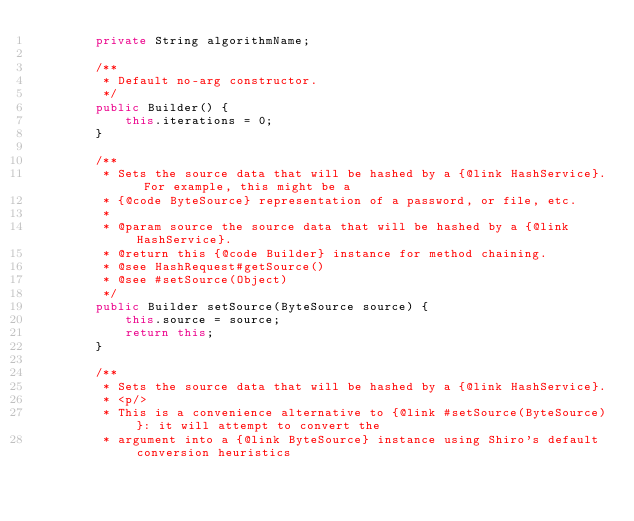Convert code to text. <code><loc_0><loc_0><loc_500><loc_500><_Java_>        private String algorithmName;

        /**
         * Default no-arg constructor.
         */
        public Builder() {
            this.iterations = 0;
        }

        /**
         * Sets the source data that will be hashed by a {@link HashService}. For example, this might be a
         * {@code ByteSource} representation of a password, or file, etc.
         *
         * @param source the source data that will be hashed by a {@link HashService}.
         * @return this {@code Builder} instance for method chaining.
         * @see HashRequest#getSource()
         * @see #setSource(Object)
         */
        public Builder setSource(ByteSource source) {
            this.source = source;
            return this;
        }

        /**
         * Sets the source data that will be hashed by a {@link HashService}.
         * <p/>
         * This is a convenience alternative to {@link #setSource(ByteSource)}: it will attempt to convert the
         * argument into a {@link ByteSource} instance using Shiro's default conversion heuristics</code> 